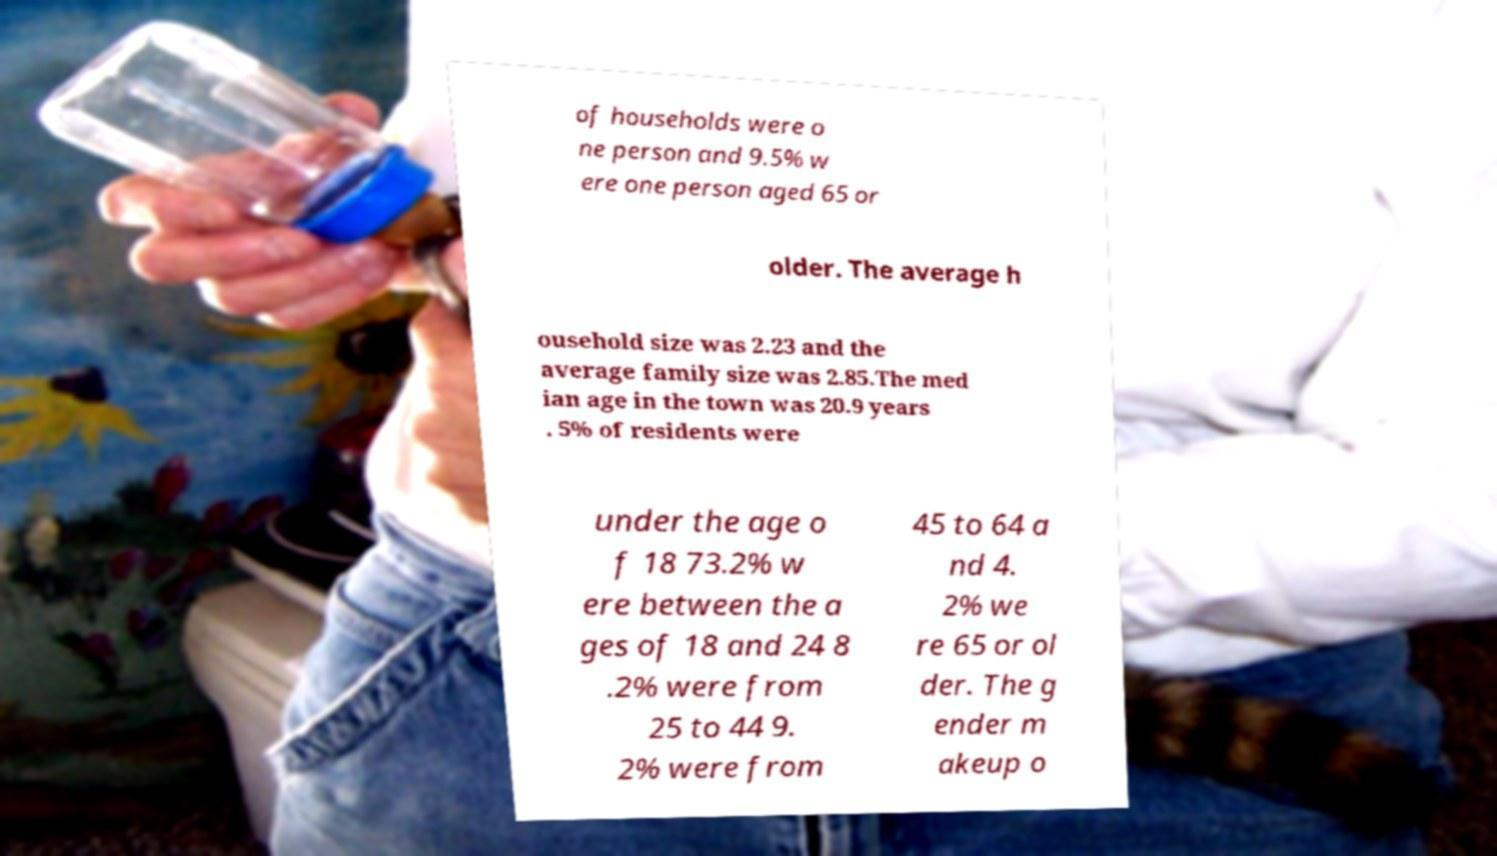What messages or text are displayed in this image? I need them in a readable, typed format. of households were o ne person and 9.5% w ere one person aged 65 or older. The average h ousehold size was 2.23 and the average family size was 2.85.The med ian age in the town was 20.9 years . 5% of residents were under the age o f 18 73.2% w ere between the a ges of 18 and 24 8 .2% were from 25 to 44 9. 2% were from 45 to 64 a nd 4. 2% we re 65 or ol der. The g ender m akeup o 